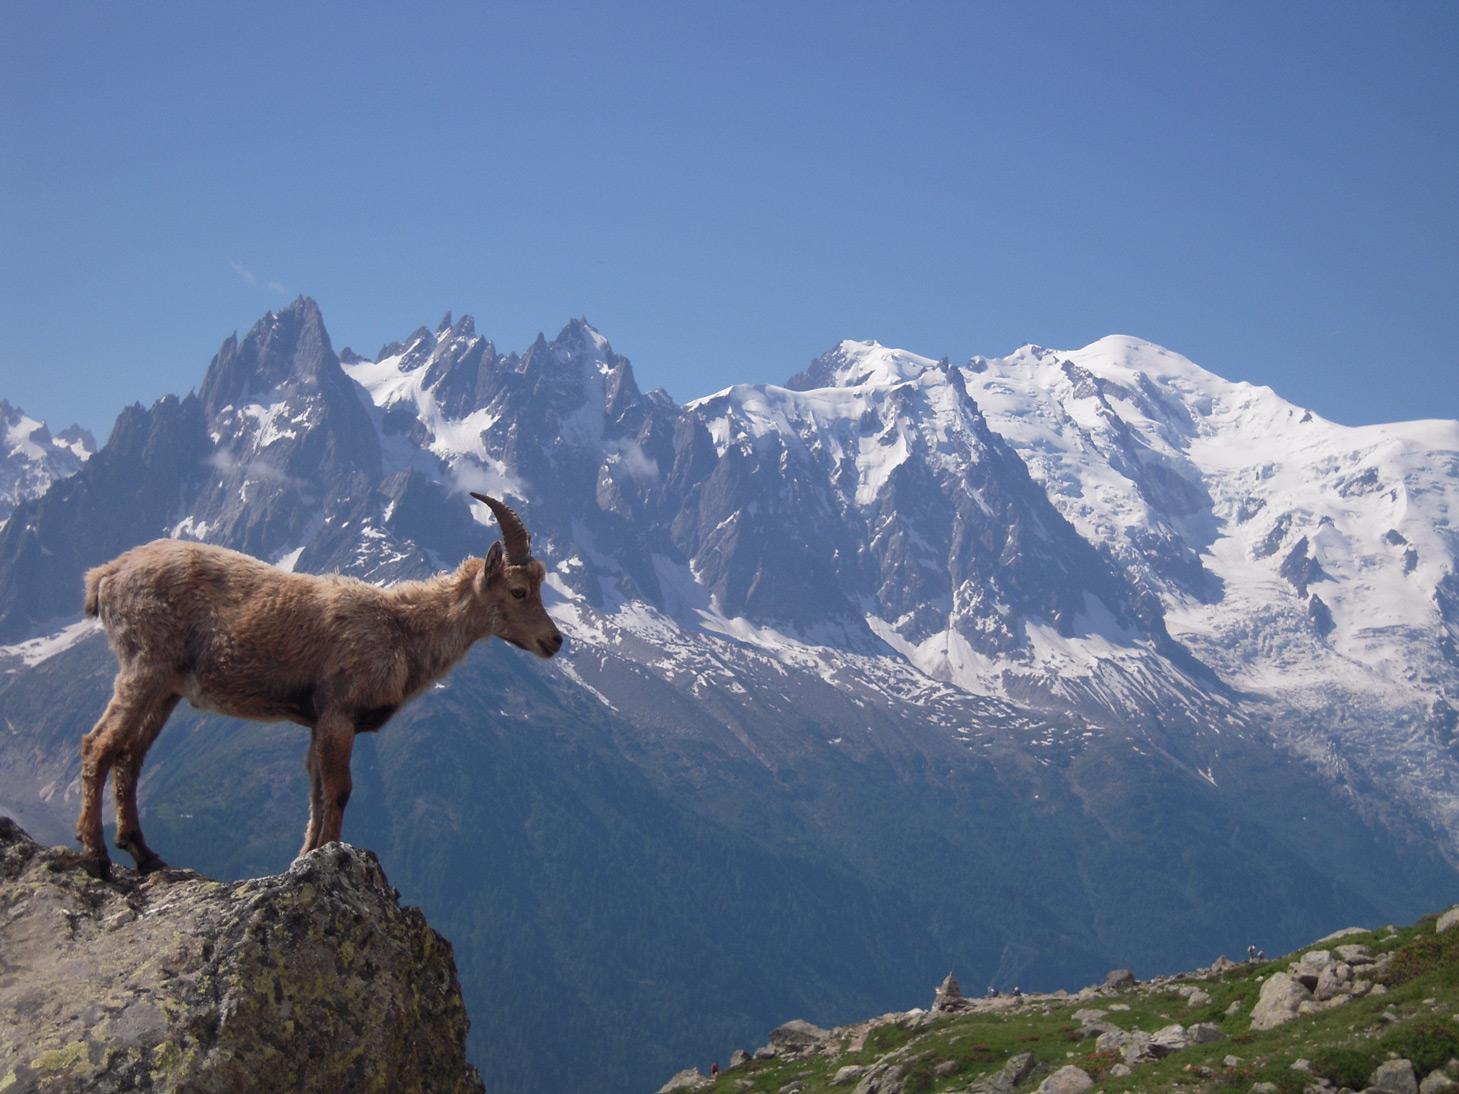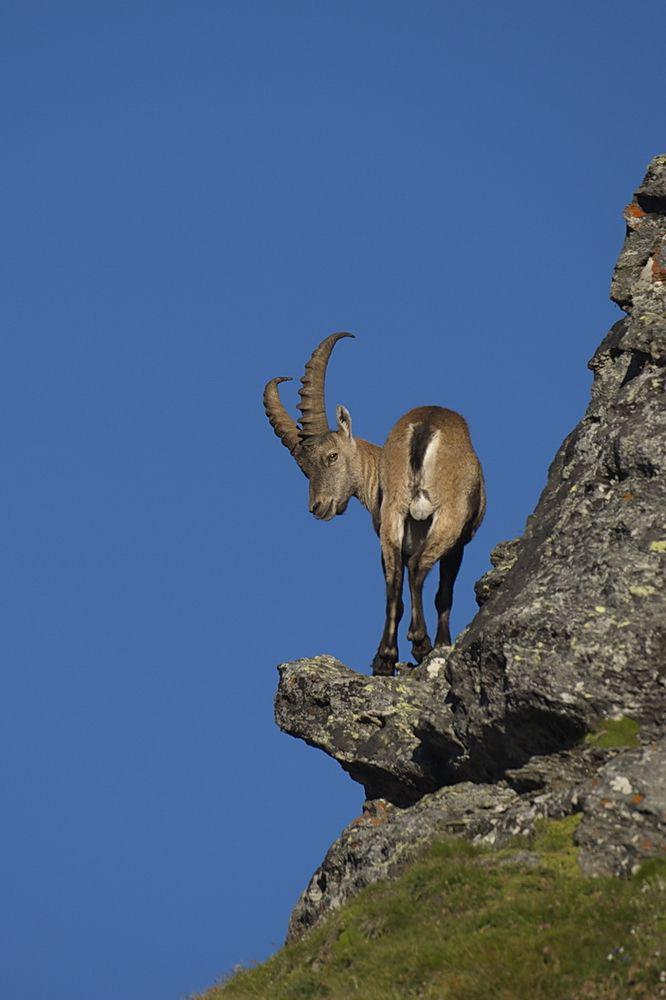The first image is the image on the left, the second image is the image on the right. Considering the images on both sides, is "The ram/goat on the left is overlooking a jump." valid? Answer yes or no. Yes. 